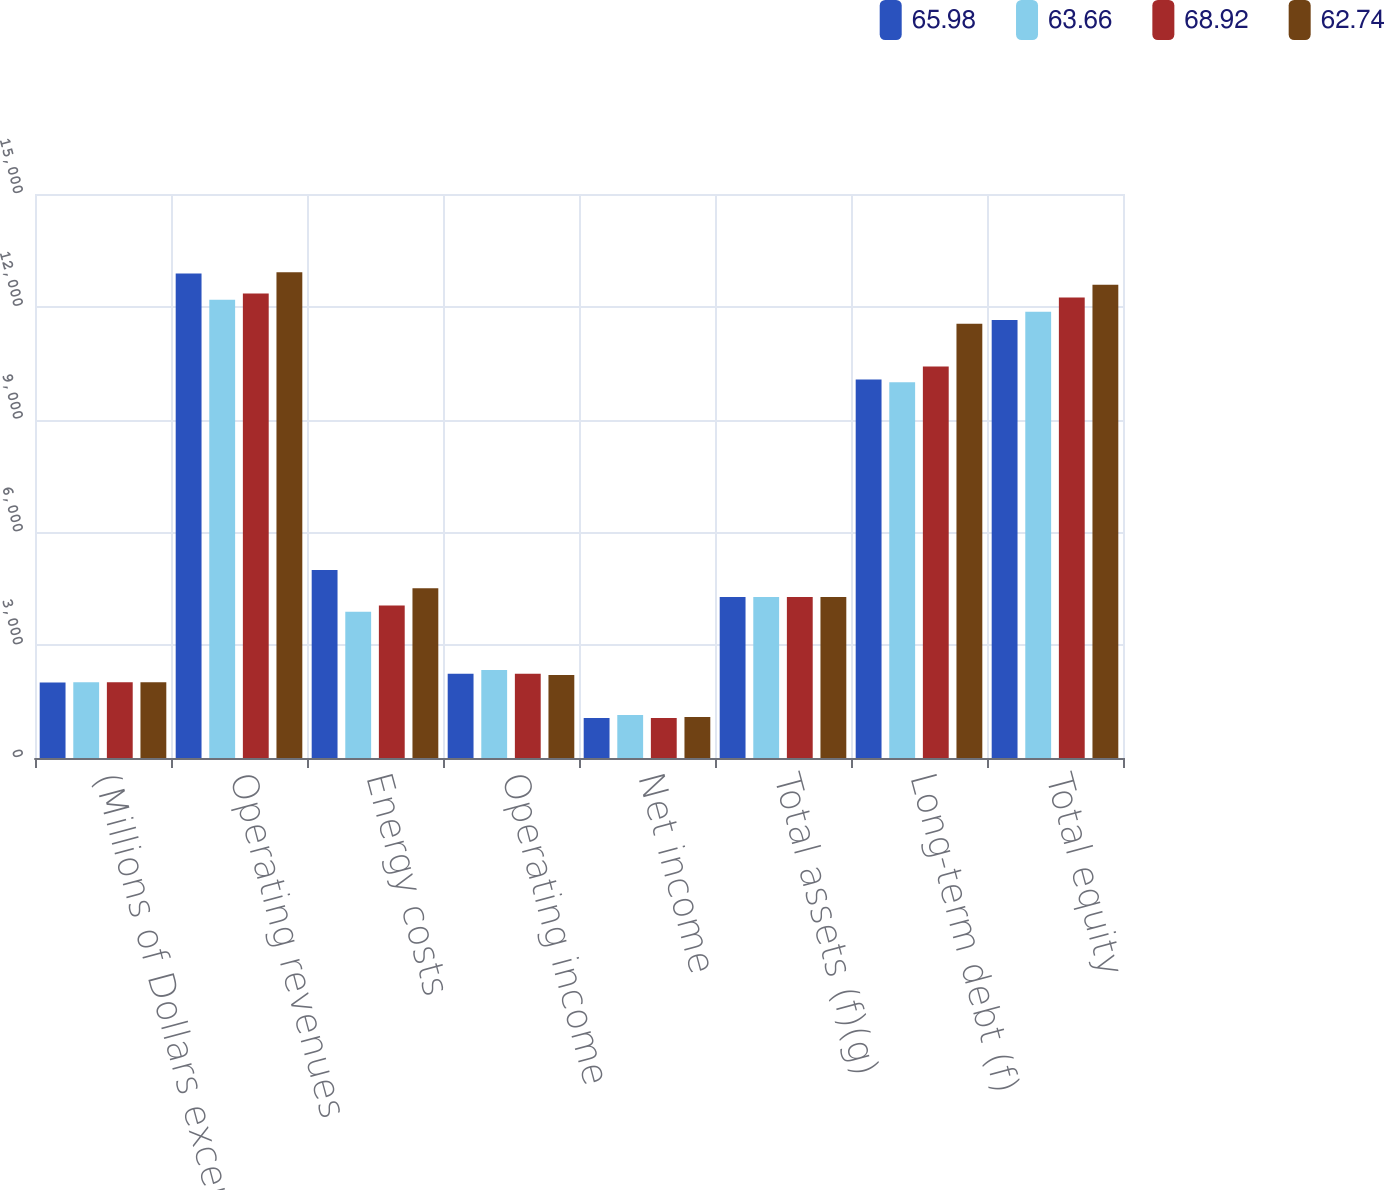Convert chart. <chart><loc_0><loc_0><loc_500><loc_500><stacked_bar_chart><ecel><fcel>(Millions of Dollars except<fcel>Operating revenues<fcel>Energy costs<fcel>Operating income<fcel>Net income<fcel>Total assets (f)(g)<fcel>Long-term debt (f)<fcel>Total equity<nl><fcel>65.98<fcel>2011<fcel>12886<fcel>5001<fcel>2239<fcel>1062<fcel>4283.5<fcel>10068<fcel>11649<nl><fcel>63.66<fcel>2012<fcel>12188<fcel>3887<fcel>2339<fcel>1141<fcel>4283.5<fcel>9994<fcel>11869<nl><fcel>68.92<fcel>2013<fcel>12354<fcel>4054<fcel>2244<fcel>1062<fcel>4283.5<fcel>10415<fcel>12245<nl><fcel>62.74<fcel>2014<fcel>12919<fcel>4513<fcel>2209<fcel>1092<fcel>4283.5<fcel>11546<fcel>12585<nl></chart> 